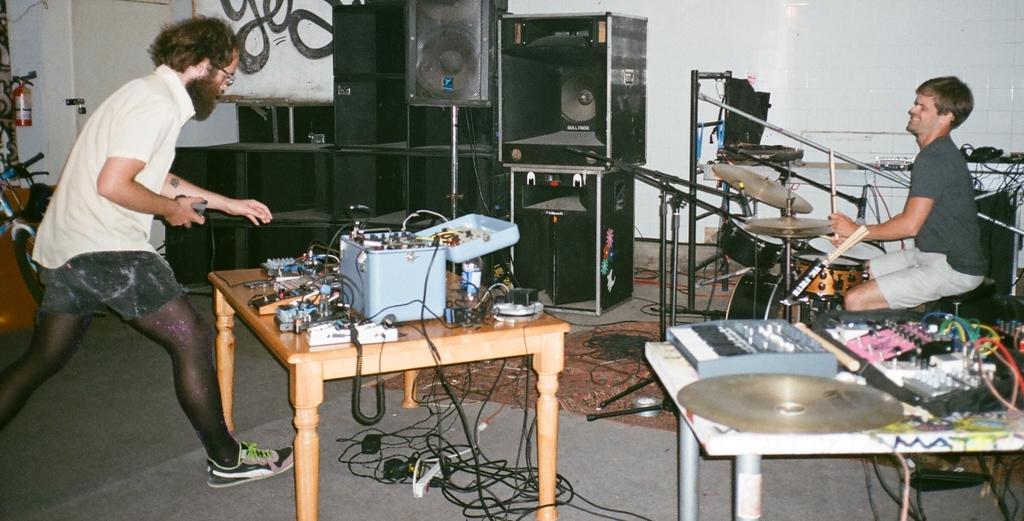Could you give a brief overview of what you see in this image? In this picture I can see a man seated and playing drums and I can see few electronic items on the couple of tables and I can see a piano on another table and few speakers and a bicycle and a Fire extinguisher to the wall and I can see a man walking holding something in his hand. 